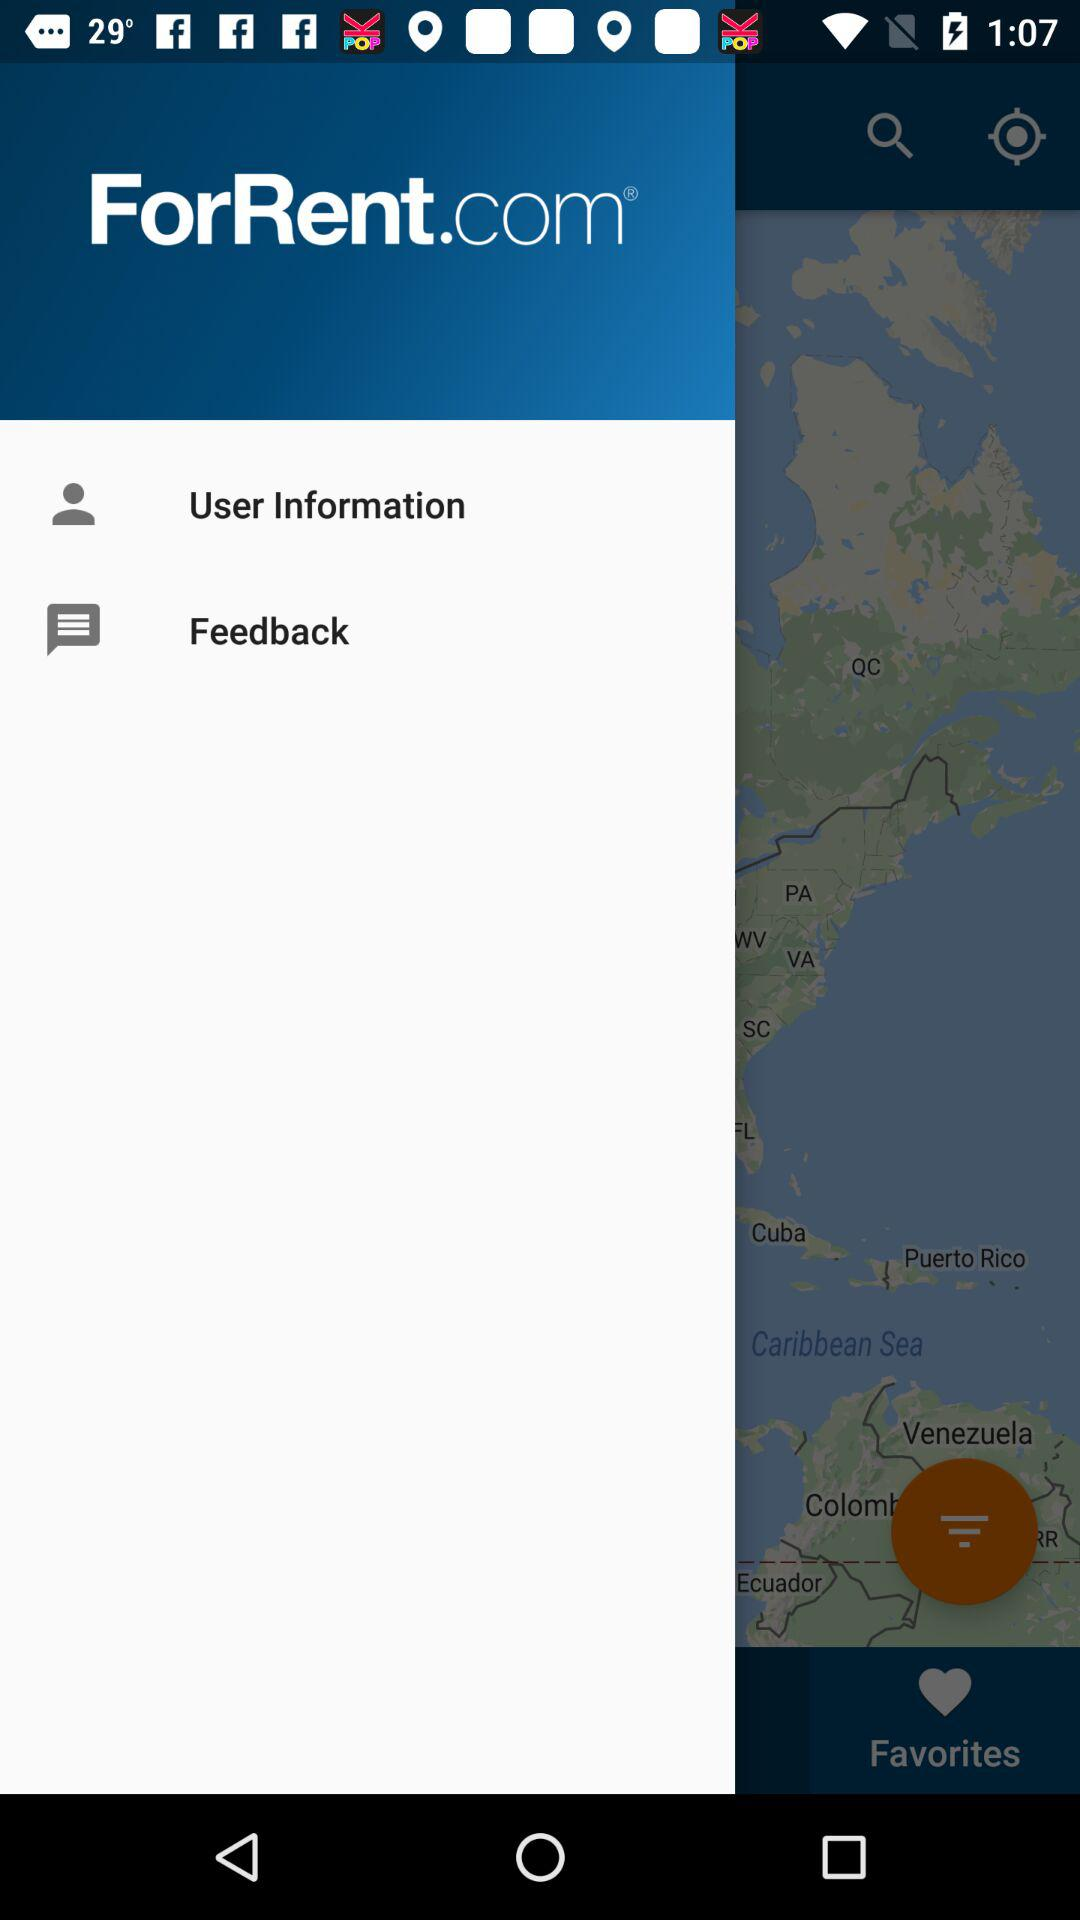What is the company name? The company name is "ForRent.com". 